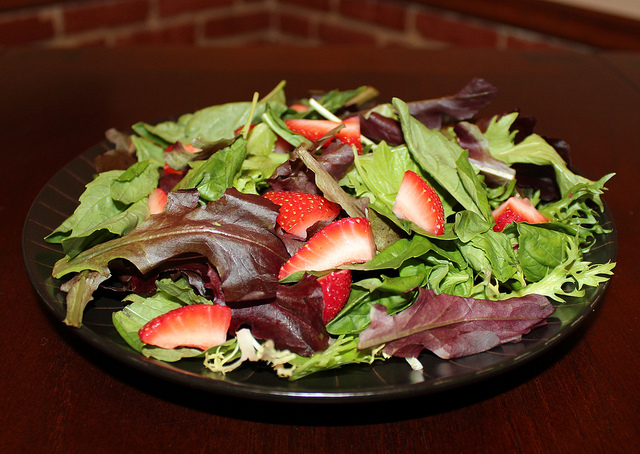What benefits do strawberries in the salad offer? Strawberries add a sweet and fruity flavor contrast to the salad, while also providing essential nutrients such as vitamin C, antioxidants, and dietary fiber which are beneficial for health. 